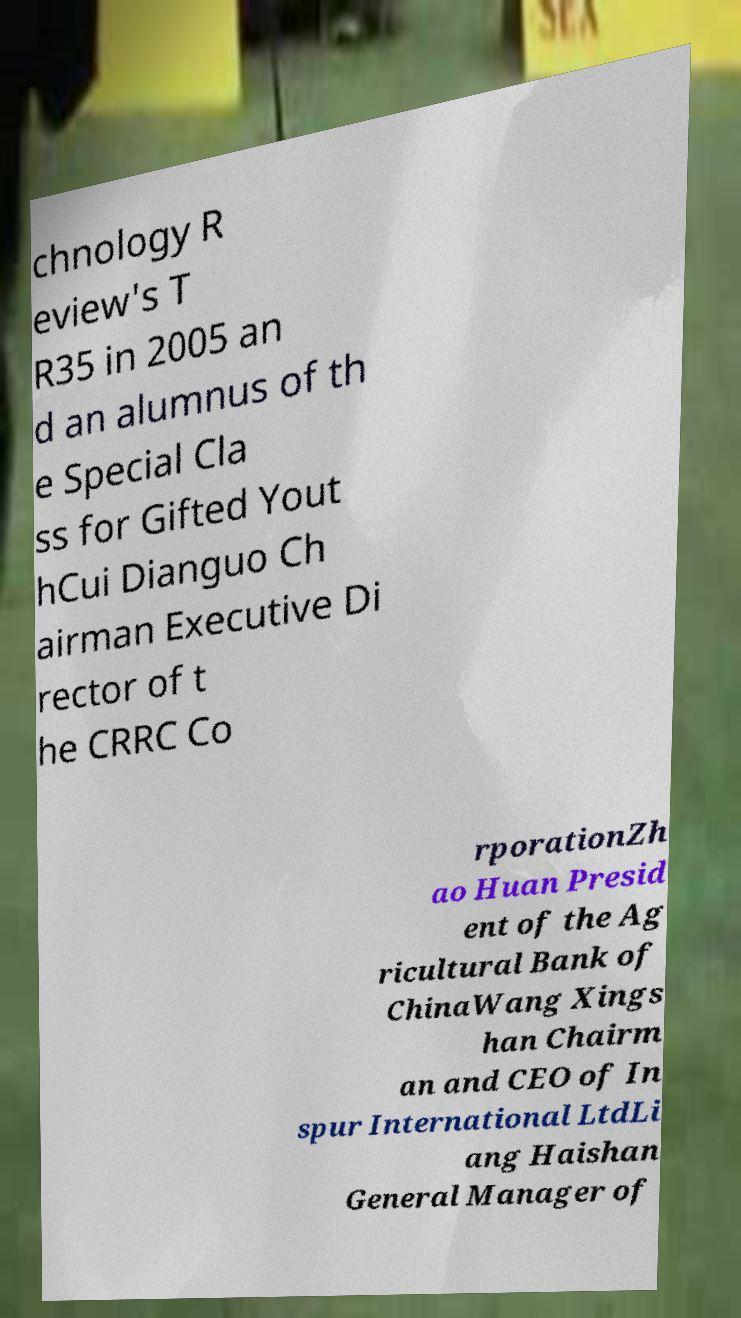For documentation purposes, I need the text within this image transcribed. Could you provide that? chnology R eview's T R35 in 2005 an d an alumnus of th e Special Cla ss for Gifted Yout hCui Dianguo Ch airman Executive Di rector of t he CRRC Co rporationZh ao Huan Presid ent of the Ag ricultural Bank of ChinaWang Xings han Chairm an and CEO of In spur International LtdLi ang Haishan General Manager of 